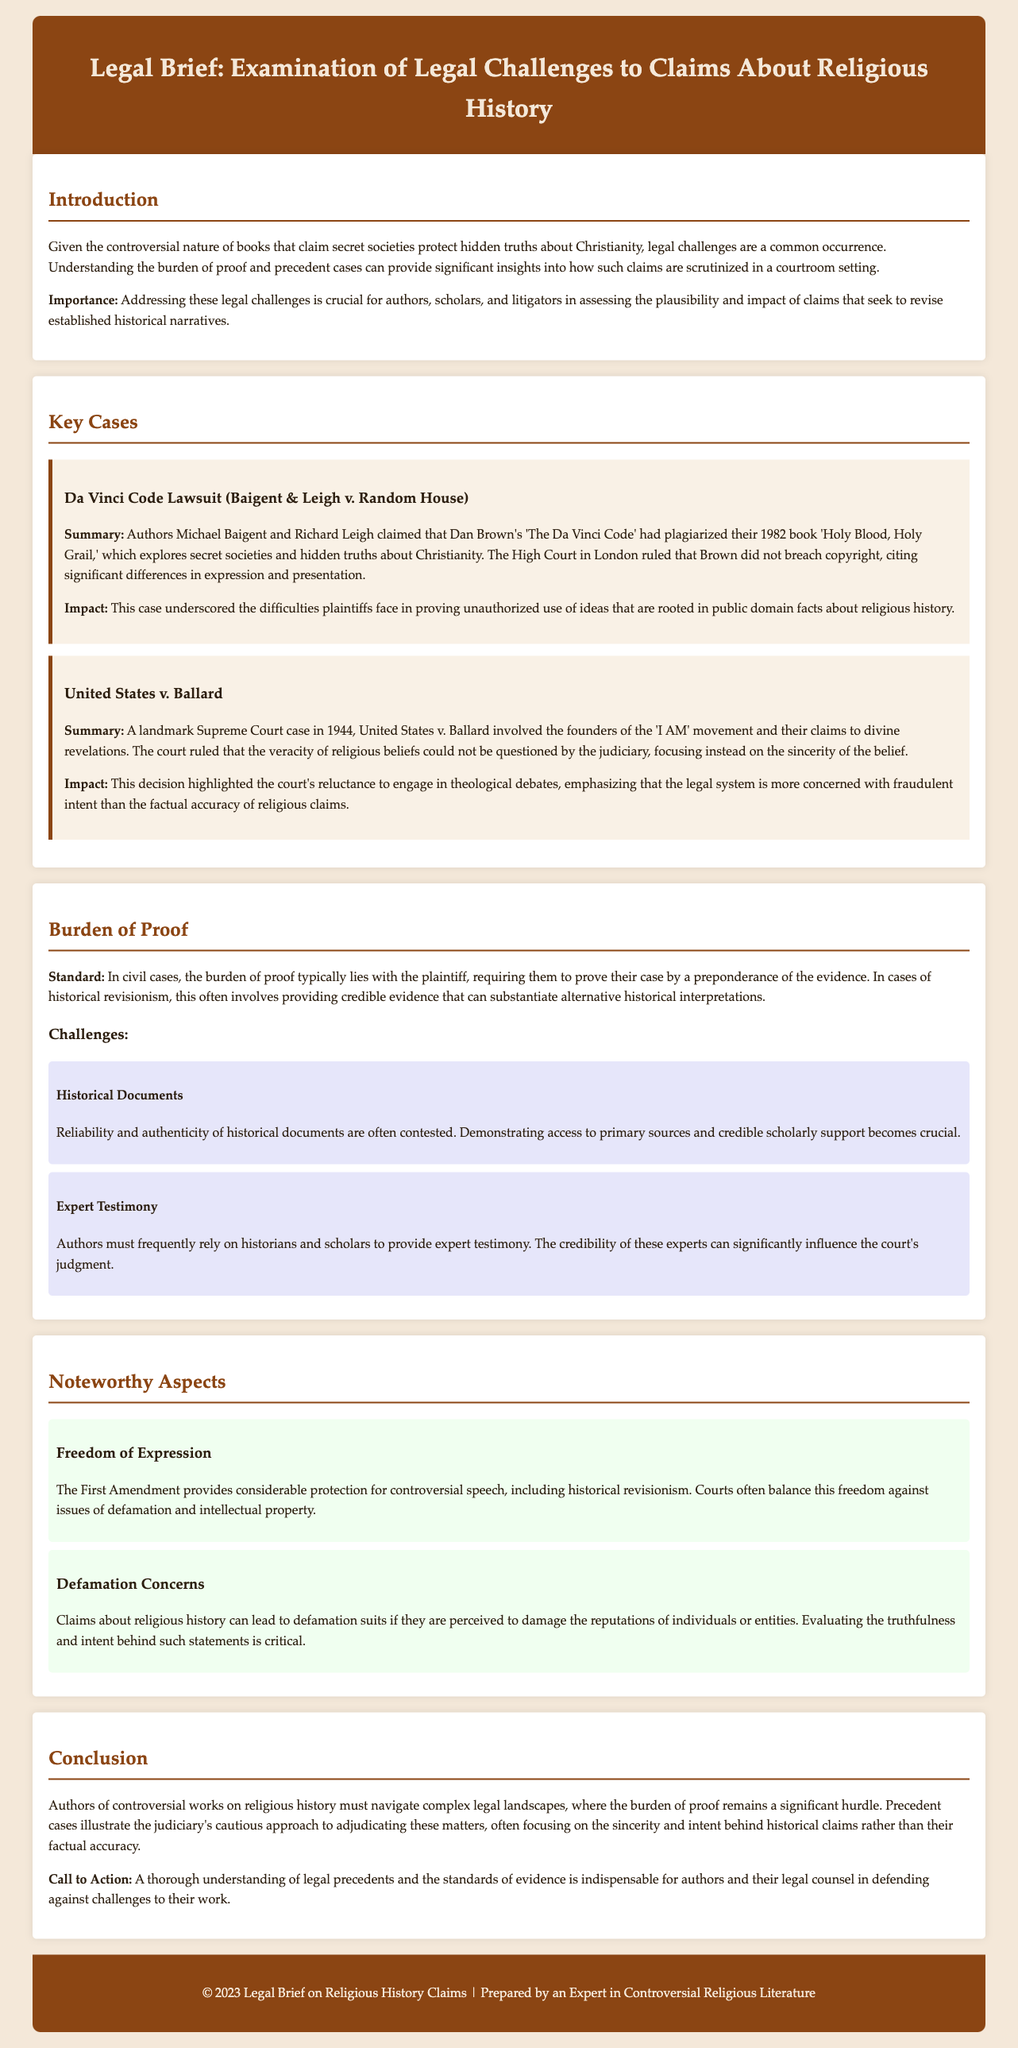What is the name of the case involving Dan Brown? The document mentions a lawsuit where authors Michael Baigent and Richard Leigh claimed plagiarism against Dan Brown regarding 'The Da Vinci Code'.
Answer: Baigent & Leigh v. Random House In which year did the United States v. Ballard case take place? The legal brief states that the United States v. Ballard was a landmark case decided in the year 1944.
Answer: 1944 What is the burden of proof standard in civil cases? The standard for civil cases requires the plaintiff to prove their case by a preponderance of the evidence.
Answer: Preponderance of the evidence What constitutional protection is mentioned for controversial speech? The document highlights the significant protection of the First Amendment for controversial speech, including historical revisionism.
Answer: First Amendment What aspect is crucial for authors to prove their claims? The need to demonstrate the reliability and authenticity of historical documents is pointed out as essential in court cases.
Answer: Reliability and authenticity of historical documents How does the court address the sincerity of religious beliefs? The legal brief asserts that the judiciary focuses on the sincerity of beliefs rather than questioning the veracity of religious claims.
Answer: Sincerity of the belief What is a key challenge faced by authors in court? It is mentioned that authors frequently rely on historians and scholars for expert testimony which can influence the court's judgment.
Answer: Expert testimony What is one of the defamation concerns mentioned? The brief discusses that claims about religious history can lead to defamation suits if they damage reputations.
Answer: Damage to reputations What is the purpose of the legal brief as stated in the introduction? The introduction describes the brief's aim as addressing legal challenges, crucial for authors and scholars in assessing claims on historical narratives.
Answer: Addressing legal challenges 